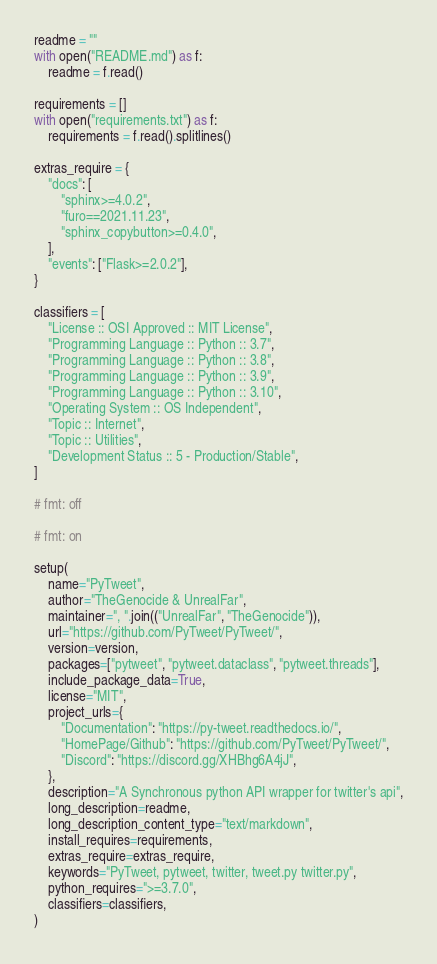<code> <loc_0><loc_0><loc_500><loc_500><_Python_>
readme = ""
with open("README.md") as f:
    readme = f.read()

requirements = []
with open("requirements.txt") as f:
    requirements = f.read().splitlines()

extras_require = {
    "docs": [
        "sphinx>=4.0.2",
        "furo==2021.11.23",
        "sphinx_copybutton>=0.4.0",
    ],
    "events": ["Flask>=2.0.2"],
}

classifiers = [
    "License :: OSI Approved :: MIT License",
    "Programming Language :: Python :: 3.7",
    "Programming Language :: Python :: 3.8",
    "Programming Language :: Python :: 3.9",
    "Programming Language :: Python :: 3.10",
    "Operating System :: OS Independent",
    "Topic :: Internet",
    "Topic :: Utilities",
    "Development Status :: 5 - Production/Stable",
]

# fmt: off

# fmt: on

setup(
    name="PyTweet",
    author="TheGenocide & UnrealFar",
    maintainer=", ".join(("UnrealFar", "TheGenocide")),
    url="https://github.com/PyTweet/PyTweet/",
    version=version,
    packages=["pytweet", "pytweet.dataclass", "pytweet.threads"],
    include_package_data=True,
    license="MIT",
    project_urls={
        "Documentation": "https://py-tweet.readthedocs.io/",
        "HomePage/Github": "https://github.com/PyTweet/PyTweet/",
        "Discord": "https://discord.gg/XHBhg6A4jJ",
    },
    description="A Synchronous python API wrapper for twitter's api",
    long_description=readme,
    long_description_content_type="text/markdown",
    install_requires=requirements,
    extras_require=extras_require,
    keywords="PyTweet, pytweet, twitter, tweet.py twitter.py",
    python_requires=">=3.7.0",
    classifiers=classifiers,
)
</code> 